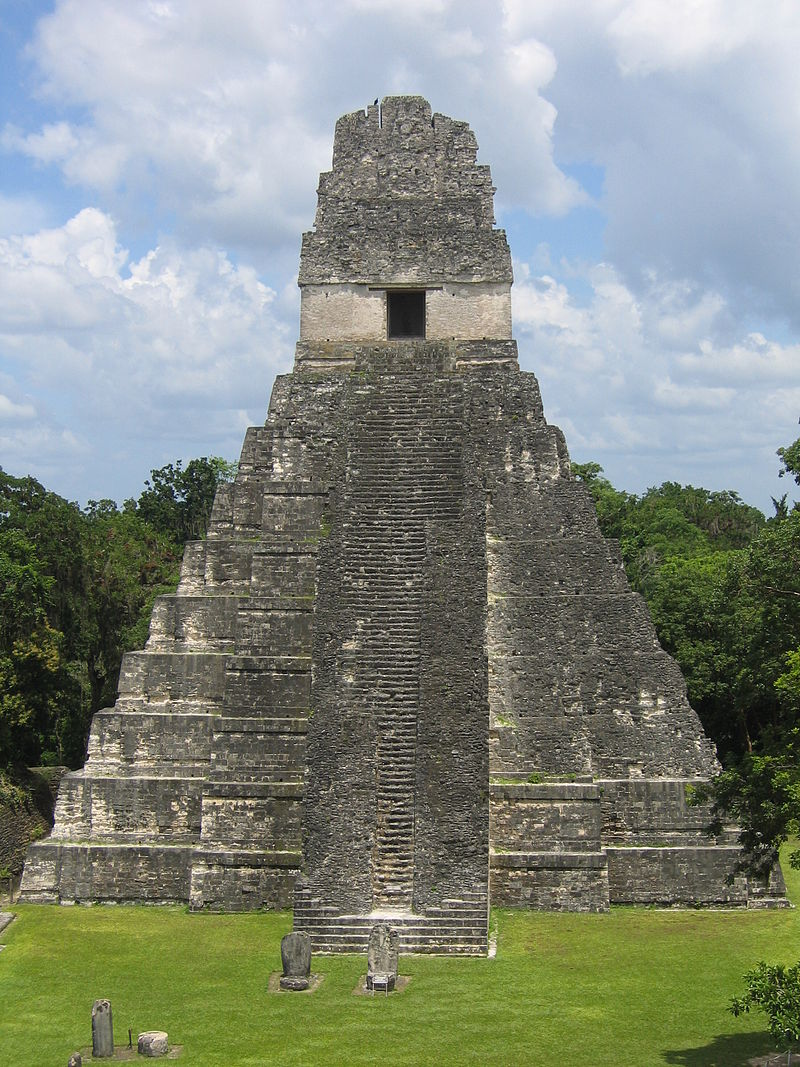Imagine a futuristic archaeological expedition discovering Tikal Temple I after an interstellar journey. Describe their findings and reactions. After an interstellar journey, futuristic archaeologists land on Earth and discover the long-forgotten Tikal Temple I. As they clear the overgrown vegetation, they're awestruck by the ancient edifice. Equipped with advanced technology, they scan the structure, unraveling its secrets. They find hidden chambers within, containing relics and artifacts that speak of sophisticated astronomical knowledge and deep religious beliefs. The team's excitement grows as they piece together glyphs that tell of a civilization that once reached for the stars with their architectural marvels, much like they do now through space exploration. This discovery becomes a cornerstone in understanding ancient human ingenuity and the persistence of cultural legacies across time and space. 